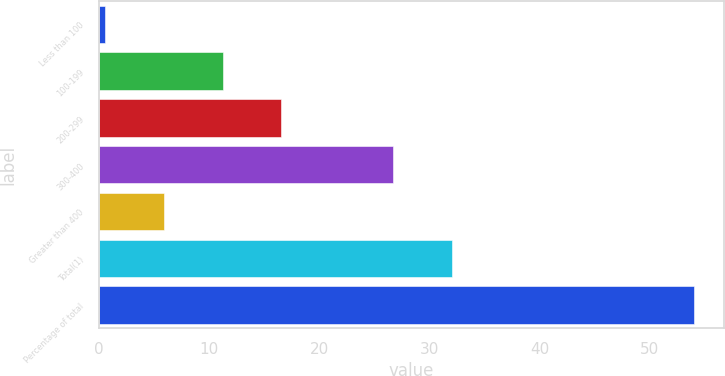Convert chart. <chart><loc_0><loc_0><loc_500><loc_500><bar_chart><fcel>Less than 100<fcel>100-199<fcel>200-299<fcel>300-400<fcel>Greater than 400<fcel>Total(1)<fcel>Percentage of total<nl><fcel>0.5<fcel>11.2<fcel>16.55<fcel>26.7<fcel>5.85<fcel>32.05<fcel>54<nl></chart> 